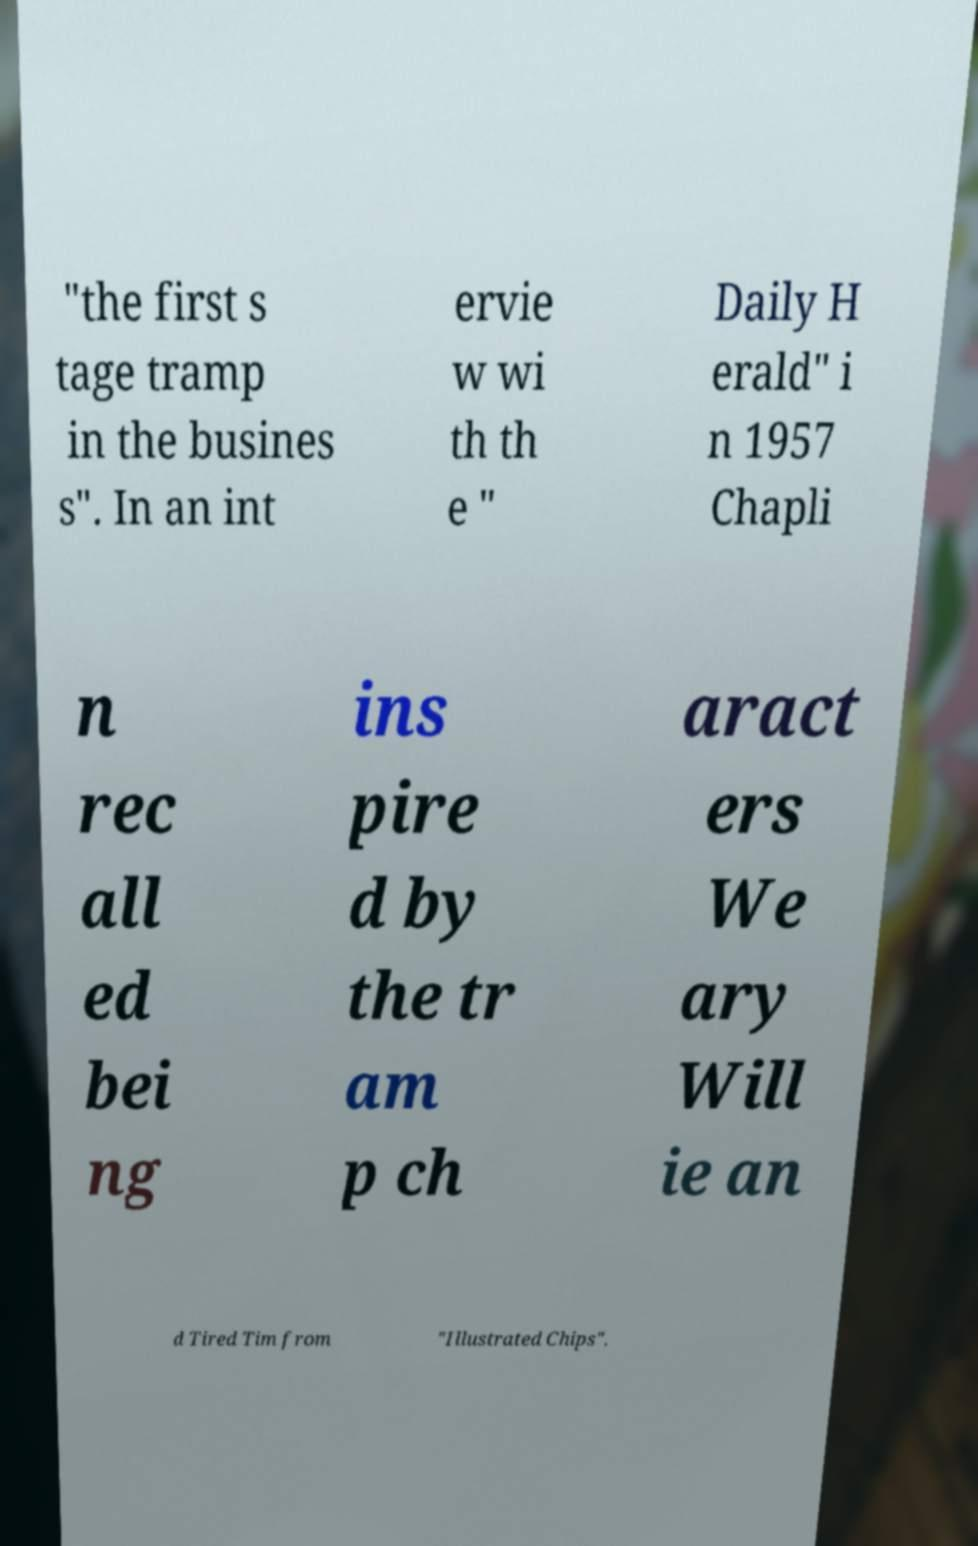For documentation purposes, I need the text within this image transcribed. Could you provide that? "the first s tage tramp in the busines s". In an int ervie w wi th th e " Daily H erald" i n 1957 Chapli n rec all ed bei ng ins pire d by the tr am p ch aract ers We ary Will ie an d Tired Tim from "Illustrated Chips". 